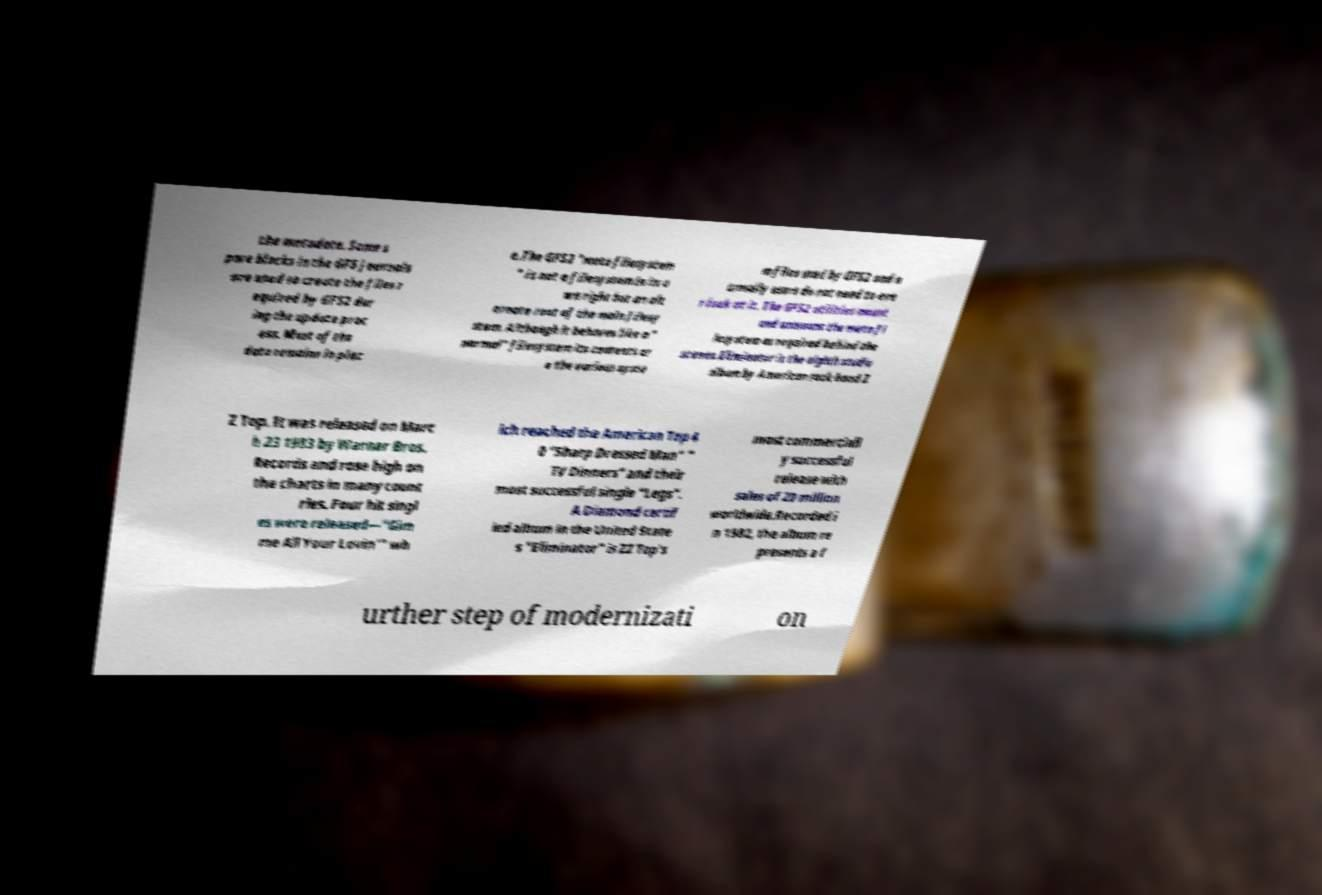Please identify and transcribe the text found in this image. the metadata. Some s pare blocks in the GFS journals are used to create the files r equired by GFS2 dur ing the update proc ess. Most of the data remains in plac e.The GFS2 "meta filesystem " is not a filesystem in its o wn right but an alt ernate root of the main filesy stem. Although it behaves like a " normal" filesystem its contents ar e the various syste m files used by GFS2 and n ormally users do not need to eve r look at it. The GFS2 utilities mount and unmount the meta fi lesystem as required behind the scenes.Eliminator is the eighth studio album by American rock band Z Z Top. It was released on Marc h 23 1983 by Warner Bros. Records and rose high on the charts in many count ries. Four hit singl es were released—"Gim me All Your Lovin'" wh ich reached the American Top 4 0 "Sharp Dressed Man" " TV Dinners" and their most successful single "Legs". A Diamond certif ied album in the United State s "Eliminator" is ZZ Top's most commerciall y successful release with sales of 20 million worldwide.Recorded i n 1982, the album re presents a f urther step of modernizati on 